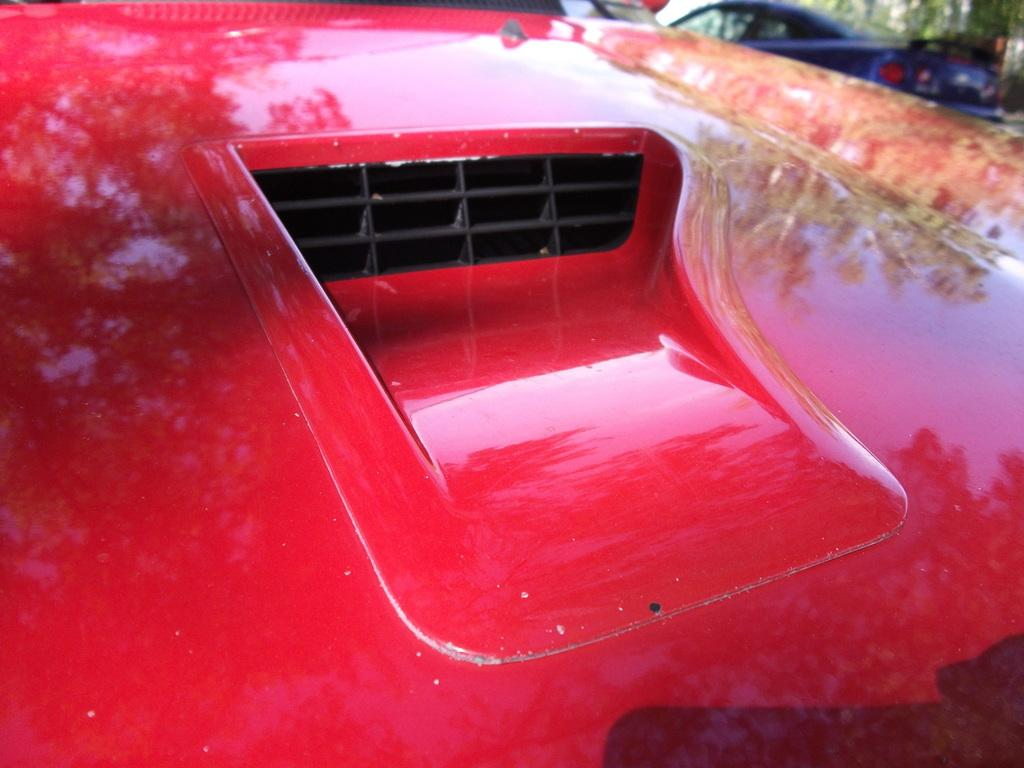How many vehicles can be seen in the image? There are two vehicles in the image. What colors are the vehicles? One vehicle is red in color, and the other is blue in color. What can be observed about the background of the image? The background of the image is blurred. What type of jam is being spread on the cart in the image? There is no cart, rule, or jam present in the image. The image features two vehicles with different colors, and the background is blurred. 